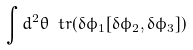Convert formula to latex. <formula><loc_0><loc_0><loc_500><loc_500>\int d ^ { 2 } \theta \ t r ( \delta \phi _ { 1 } [ \delta \phi _ { 2 } , \delta \phi _ { 3 } ] )</formula> 